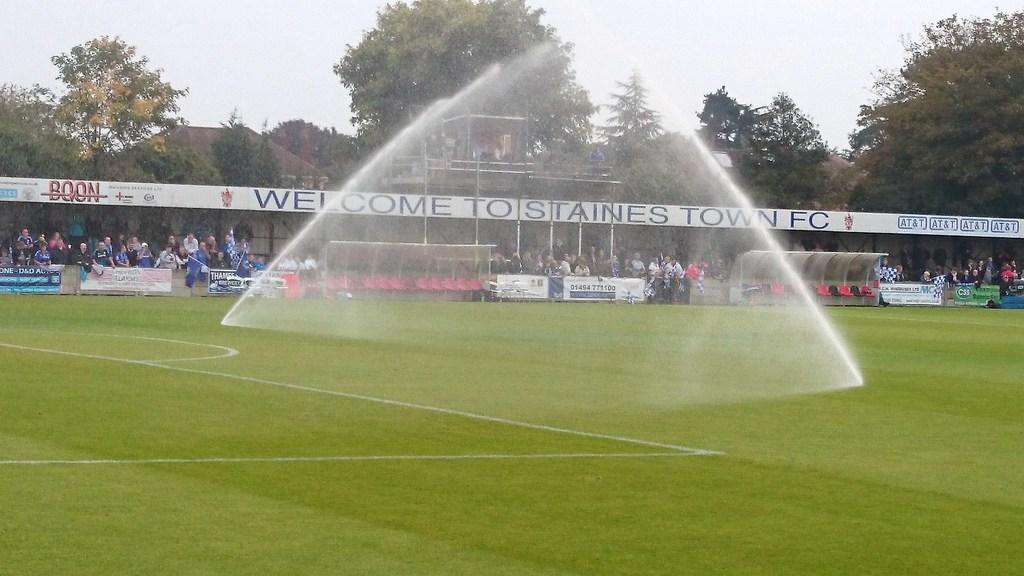Provide a one-sentence caption for the provided image. A sports field that says Welcome To Tostaines Town FC. 